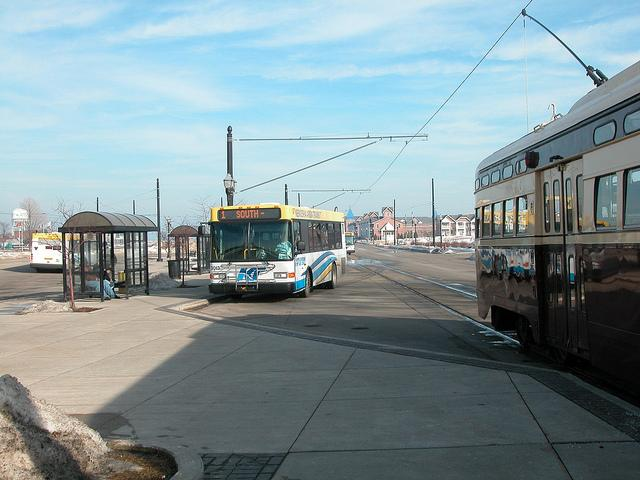What is the overhead wire for?

Choices:
A) power streetcars
B) guides streetcar
C) electric utility
D) phone lines power streetcars 